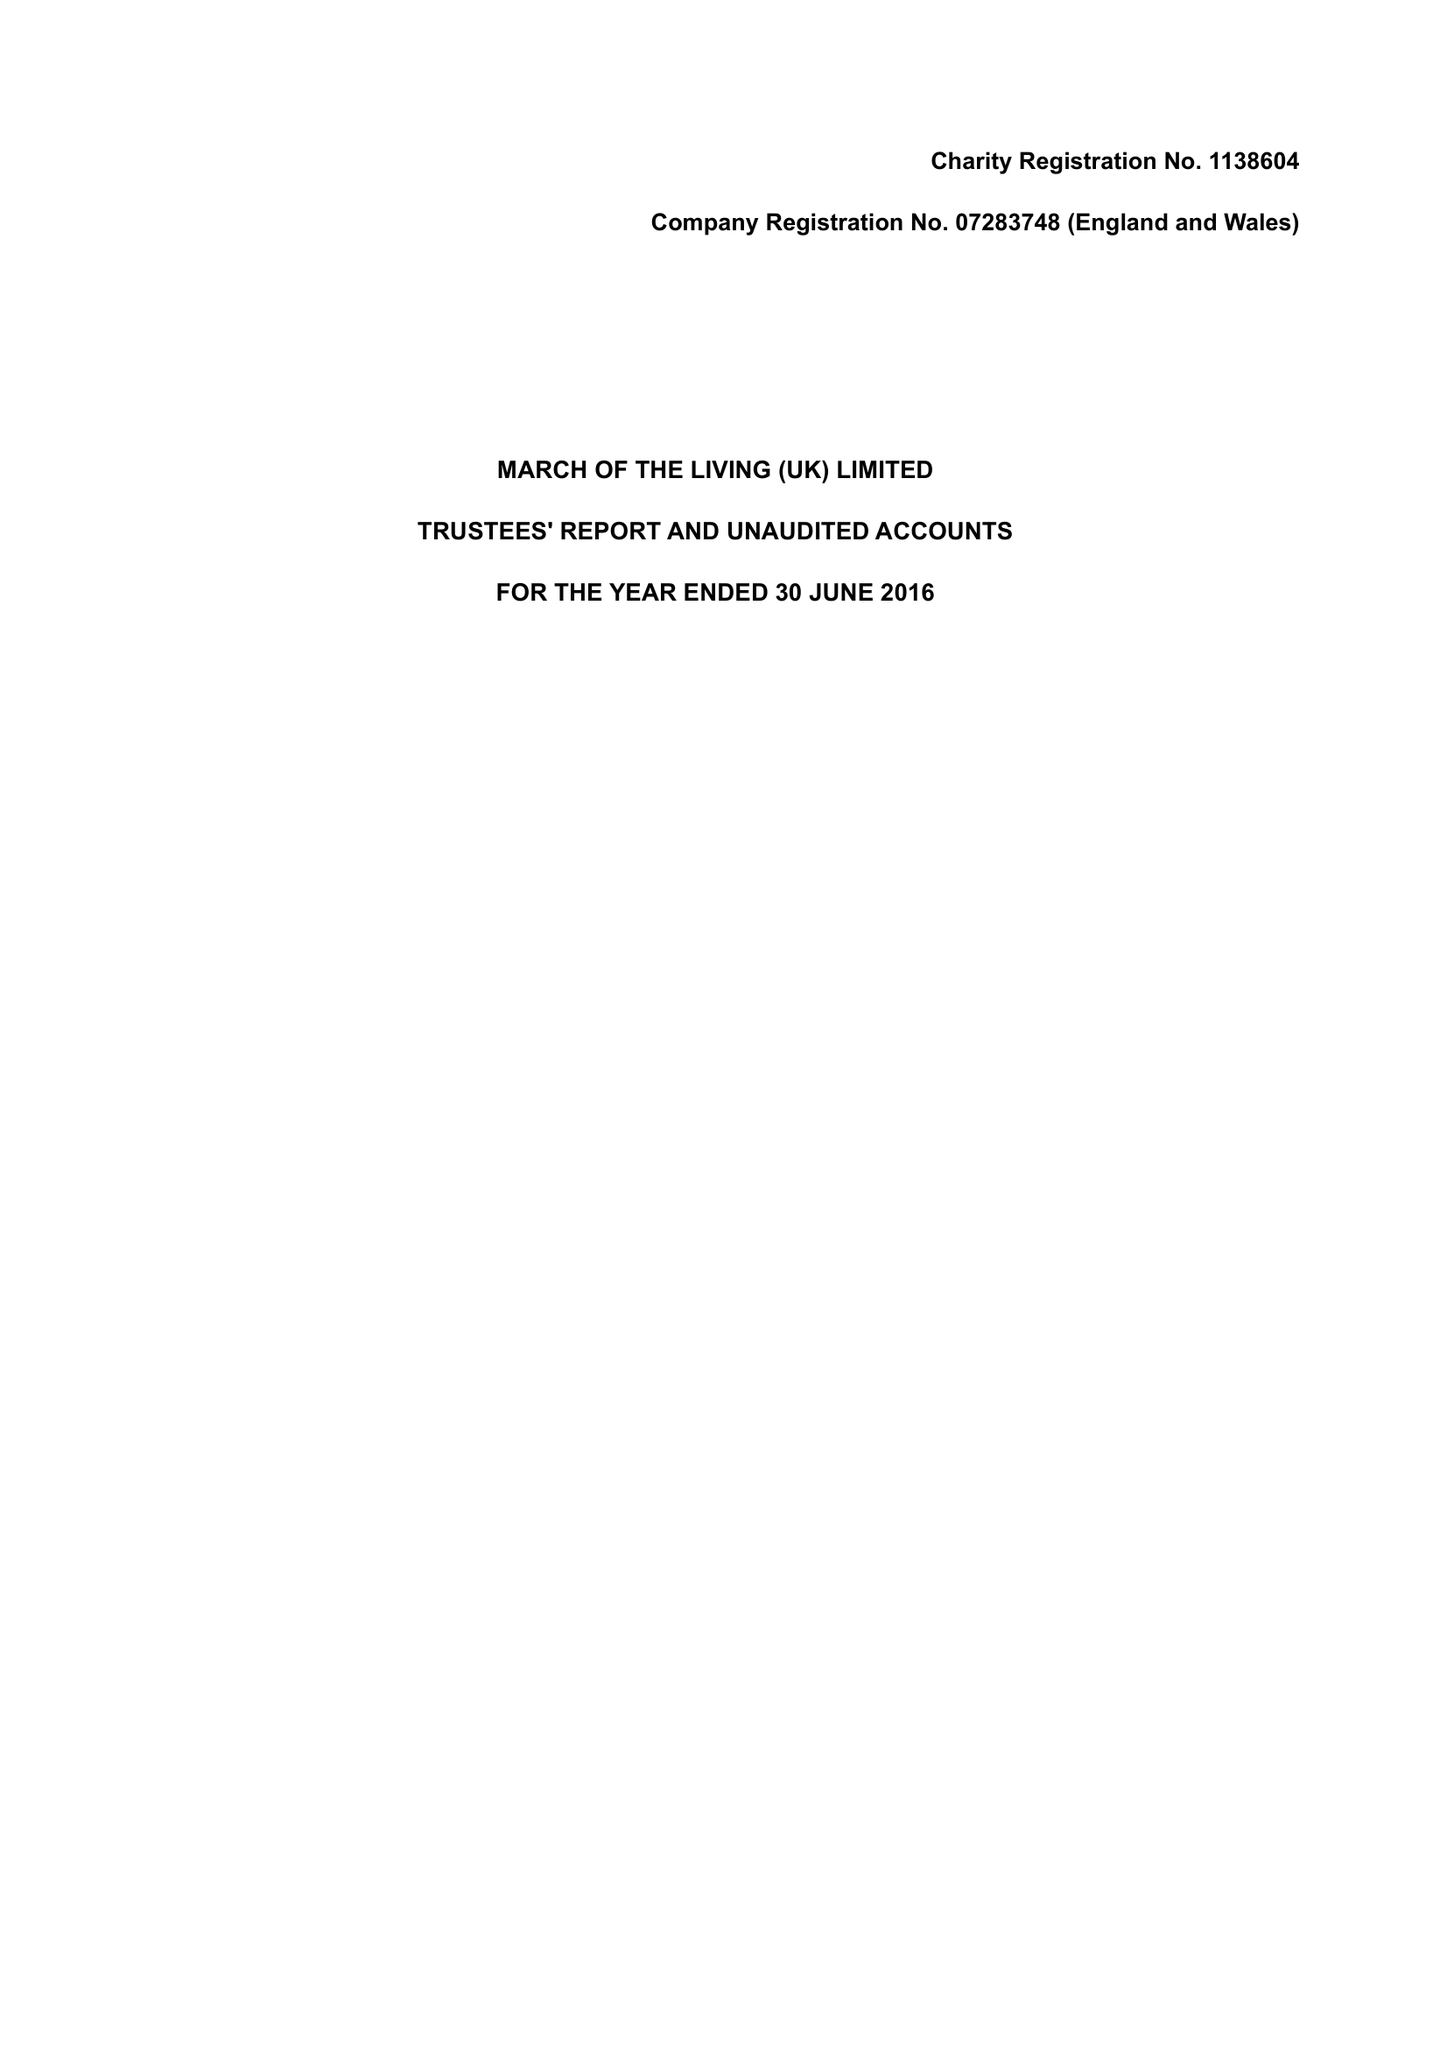What is the value for the address__postcode?
Answer the question using a single word or phrase. N3 1LQ 